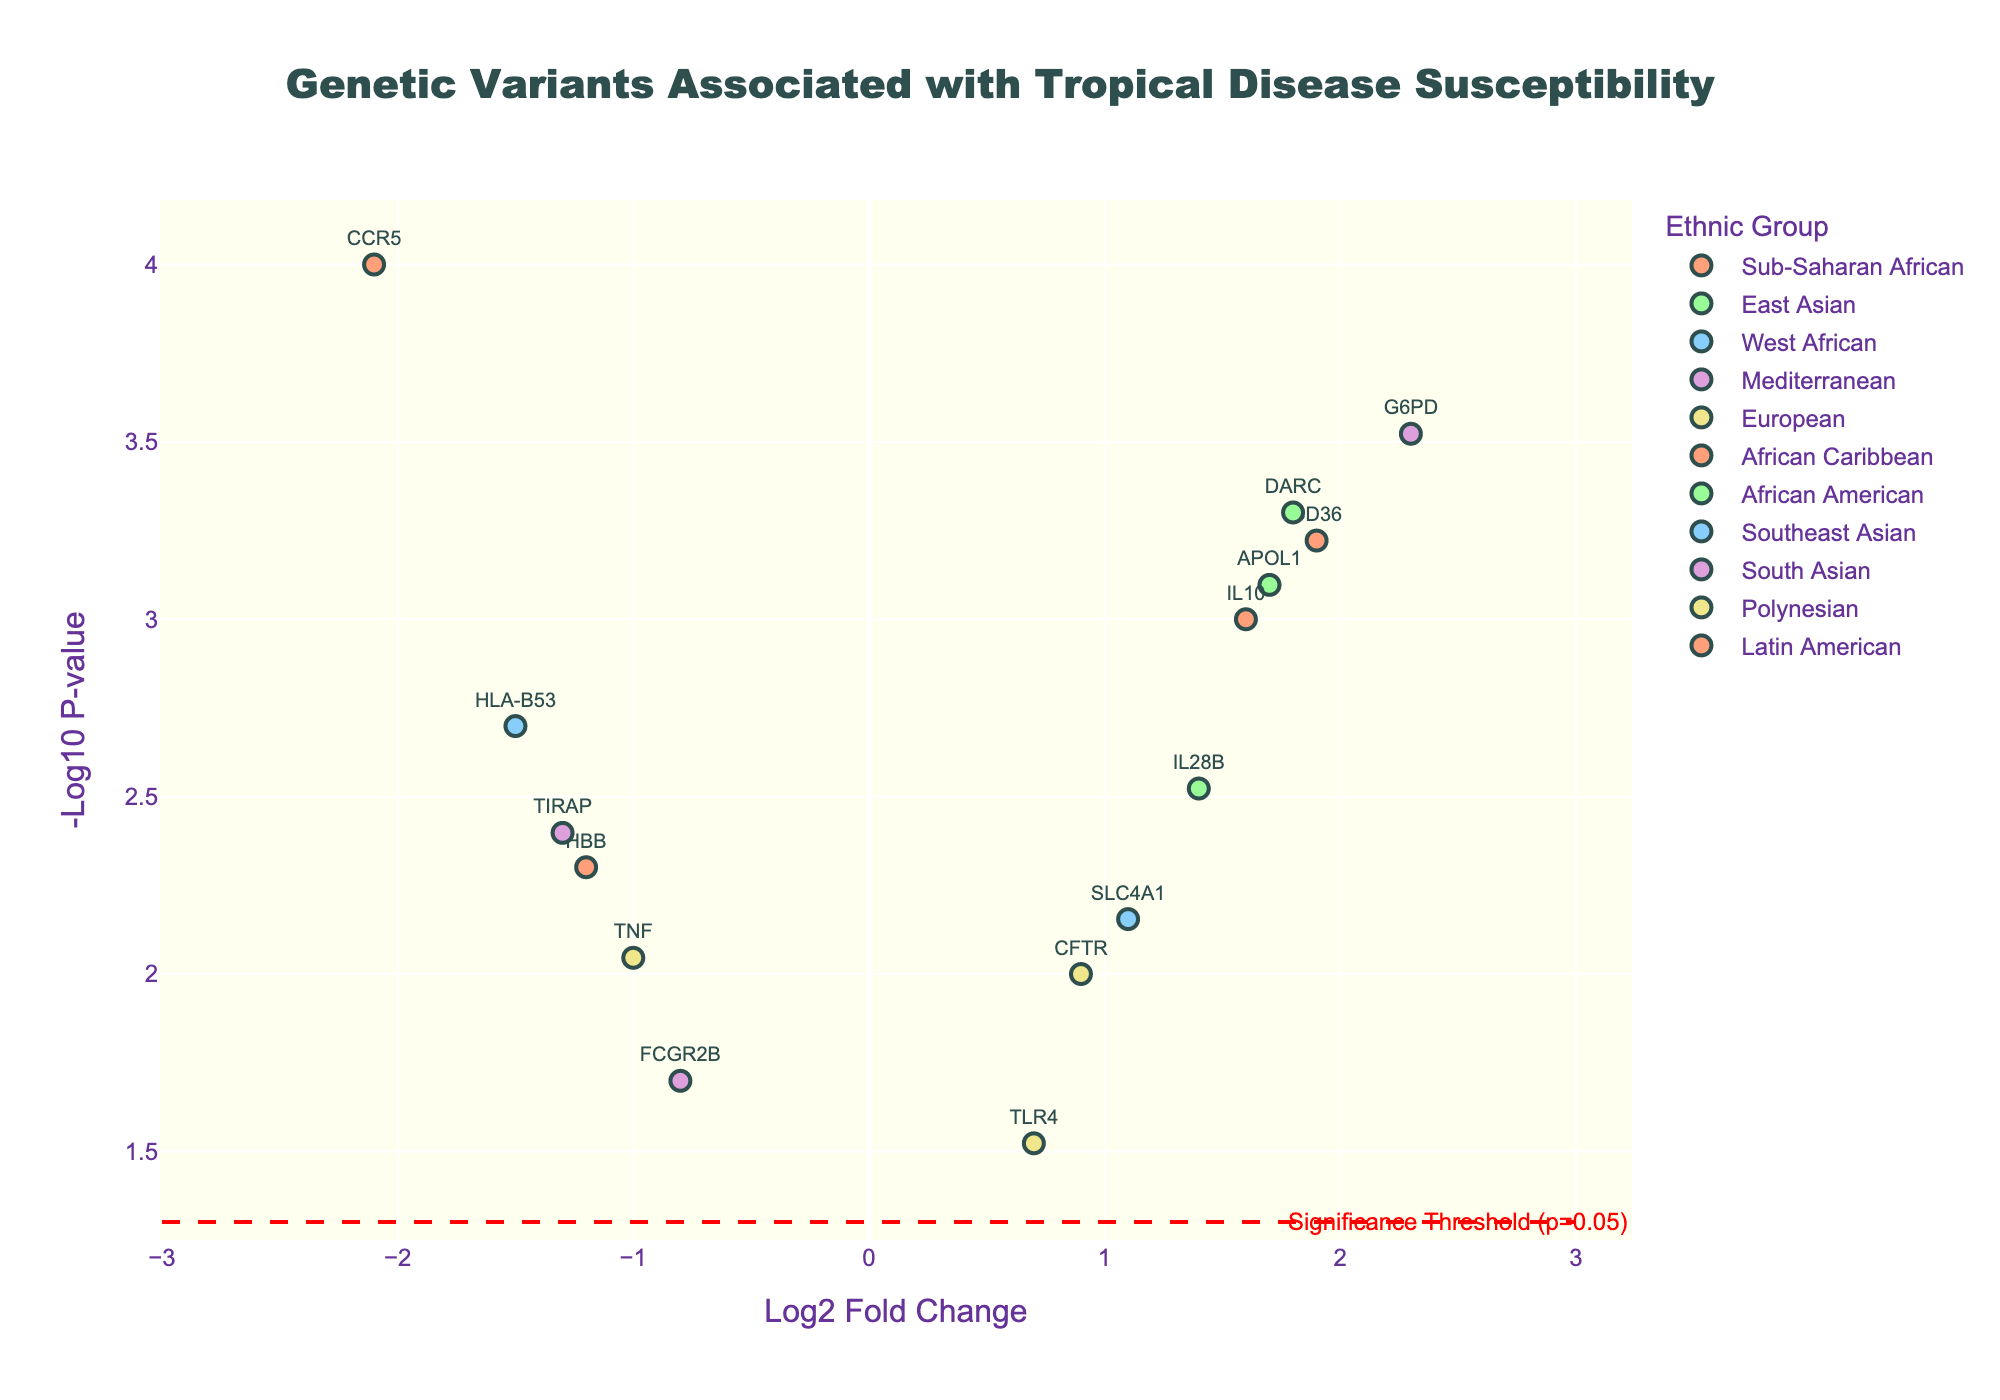what is the title of the plot? The title is displayed at the top center of the plot. It reads "Genetic Variants Associated with Tropical Disease Susceptibility".
Answer: Genetic Variants Associated with Tropical Disease Susceptibility which gene has the highest -log10 p-value? By examining the y-axis of the plot to find the point with the highest -log10 p-value, we can see that the gene G6PD has the highest value.
Answer: G6PD how many ethnic groups are represented in the plot? Each ethnic group is represented by a distinct color in the plot. There are 12 different colored markers corresponding to 12 different ethnic groups.
Answer: 12 which ethnic group has the gene with the lowest log2 fold change? Looking at the x-axis, the gene with the lowest log2 fold change is CCR5, which belongs to the Sub-Saharan African ethnic group.
Answer: Sub-Saharan African what is the log2 fold change of the gene named IL10? Find the gene name IL10 in the plot and read its corresponding log2 fold change value on the x-axis. The value is approximately 1.6.
Answer: 1.6 which genes belong to the East Asian ethnic group? Identify the markers colored for the East Asian ethnic group and list the associated gene names. The genes are DARC and IL28B.
Answer: DARC, IL28B which gene is closest to the significance threshold line (p=0.05)? The significance threshold line is indicated by a red dashed line. The gene closest to this line is TLR4.
Answer: TLR4 compare the log2 fold change values of HLA-B53 and APOL1. Which is greater? The log2 fold change values are -1.5 for HLA-B53 and 1.7 for APOL1. Since 1.7 is greater than -1.5, APOL1 has a greater log2 fold change.
Answer: APOL1 how many genes have a -log10 p-value greater than 3? Identify all the points on the plot that are above the y-axis value of 3. There are 3 genes: CCR5, G6PD, and CD36.
Answer: 3 what is the average log2 fold change for genes in the South Asian ethnic group? The genes in the South Asian group are FCGR2B and TIRAP with log2 fold changes of -0.8 and -1.3. The average is calculated as (-0.8 + -1.3) / 2 = -1.05.
Answer: -1.05 